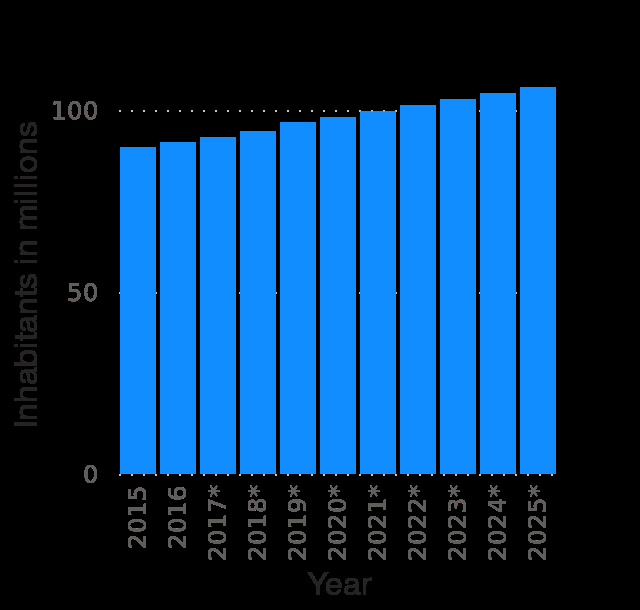<image>
What country is labeled in the bar diagram? Ethiopia is labeled in the bar diagram. What does the y-axis represent in the bar diagram? The y-axis represents the total population in millions.  